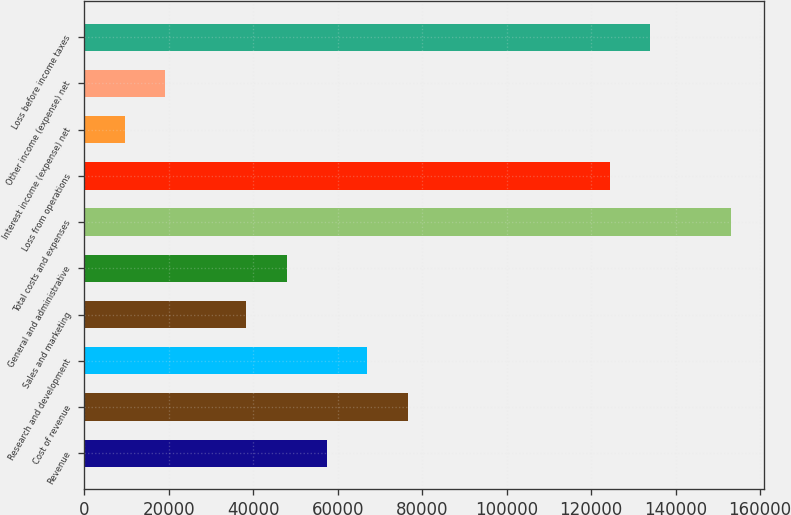Convert chart to OTSL. <chart><loc_0><loc_0><loc_500><loc_500><bar_chart><fcel>Revenue<fcel>Cost of revenue<fcel>Research and development<fcel>Sales and marketing<fcel>General and administrative<fcel>Total costs and expenses<fcel>Loss from operations<fcel>Interest income (expense) net<fcel>Other income (expense) net<fcel>Loss before income taxes<nl><fcel>57454.6<fcel>76605.8<fcel>67030.2<fcel>38303.3<fcel>47878.9<fcel>153211<fcel>124484<fcel>9576.5<fcel>19152.1<fcel>134059<nl></chart> 